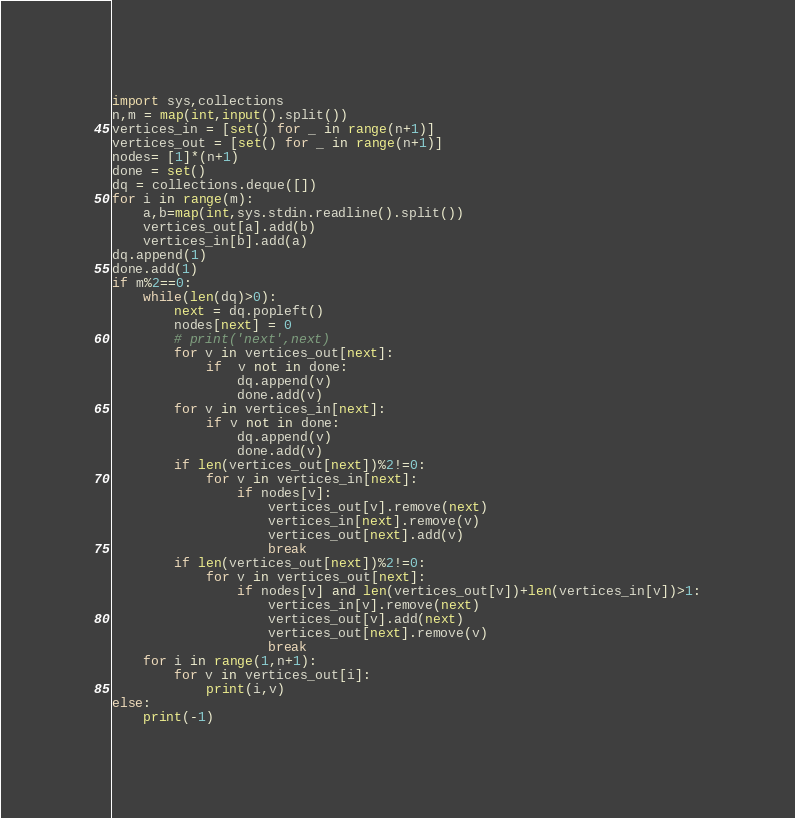Convert code to text. <code><loc_0><loc_0><loc_500><loc_500><_Python_>import sys,collections
n,m = map(int,input().split())
vertices_in = [set() for _ in range(n+1)]
vertices_out = [set() for _ in range(n+1)]
nodes= [1]*(n+1)
done = set()
dq = collections.deque([])
for i in range(m):
    a,b=map(int,sys.stdin.readline().split())
    vertices_out[a].add(b)
    vertices_in[b].add(a)
dq.append(1)
done.add(1)
if m%2==0:
    while(len(dq)>0):
        next = dq.popleft()
        nodes[next] = 0
        # print('next',next)
        for v in vertices_out[next]:
            if  v not in done:
                dq.append(v)
                done.add(v)
        for v in vertices_in[next]:
            if v not in done:
                dq.append(v)
                done.add(v)
        if len(vertices_out[next])%2!=0:
            for v in vertices_in[next]:
                if nodes[v]:
                    vertices_out[v].remove(next)
                    vertices_in[next].remove(v)
                    vertices_out[next].add(v)
                    break
        if len(vertices_out[next])%2!=0:
            for v in vertices_out[next]:
                if nodes[v] and len(vertices_out[v])+len(vertices_in[v])>1:
                    vertices_in[v].remove(next)
                    vertices_out[v].add(next)
                    vertices_out[next].remove(v)
                    break
    for i in range(1,n+1):
        for v in vertices_out[i]:
            print(i,v)
else:
    print(-1)

</code> 